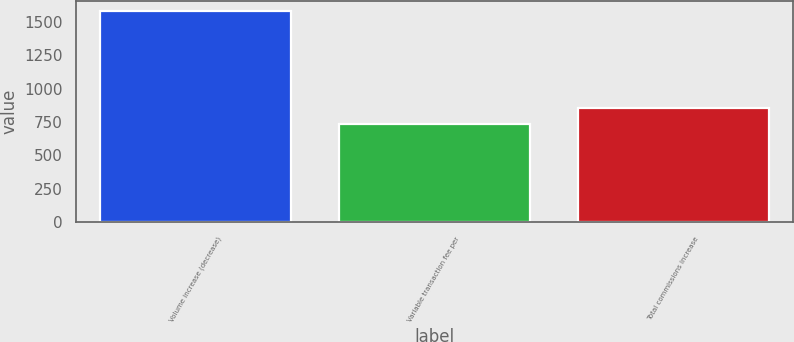<chart> <loc_0><loc_0><loc_500><loc_500><bar_chart><fcel>Volume increase (decrease)<fcel>Variable transaction fee per<fcel>Total commissions increase<nl><fcel>1580<fcel>733<fcel>857<nl></chart> 